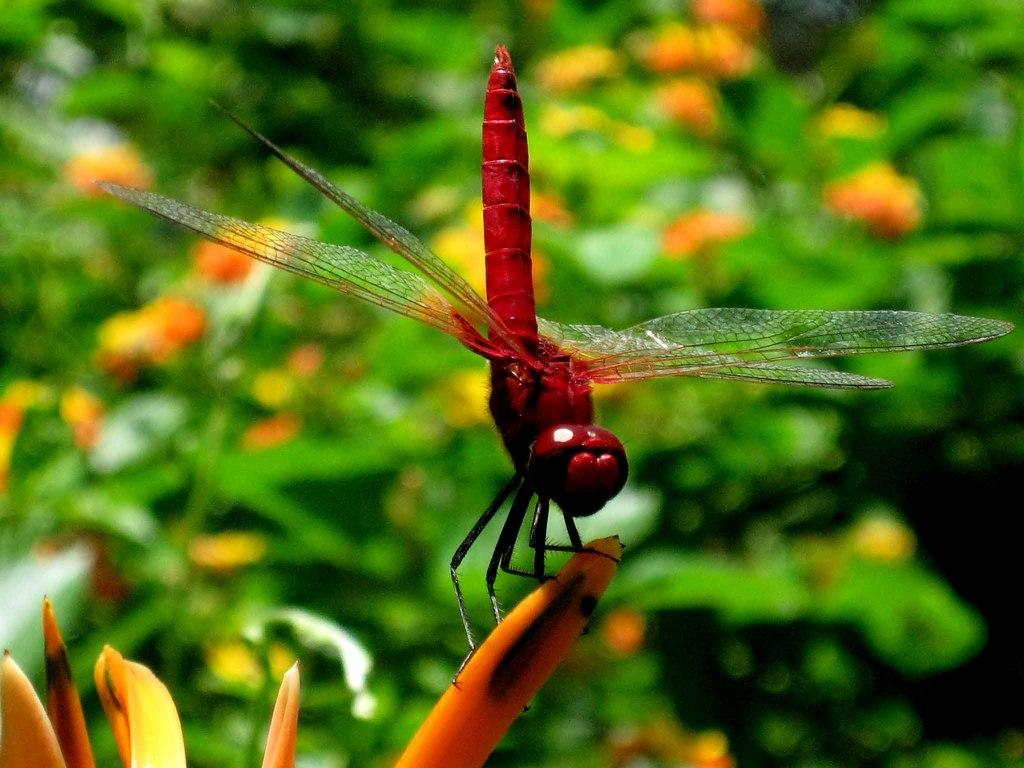What is located on a petal in the image? There is an insect on a petal in the image. What can be seen in the background of the image? There are plants with flowers in the background of the image. What type of rice can be seen growing in the image? There is no rice present in the image; it features an insect on a petal and plants with flowers in the background. 